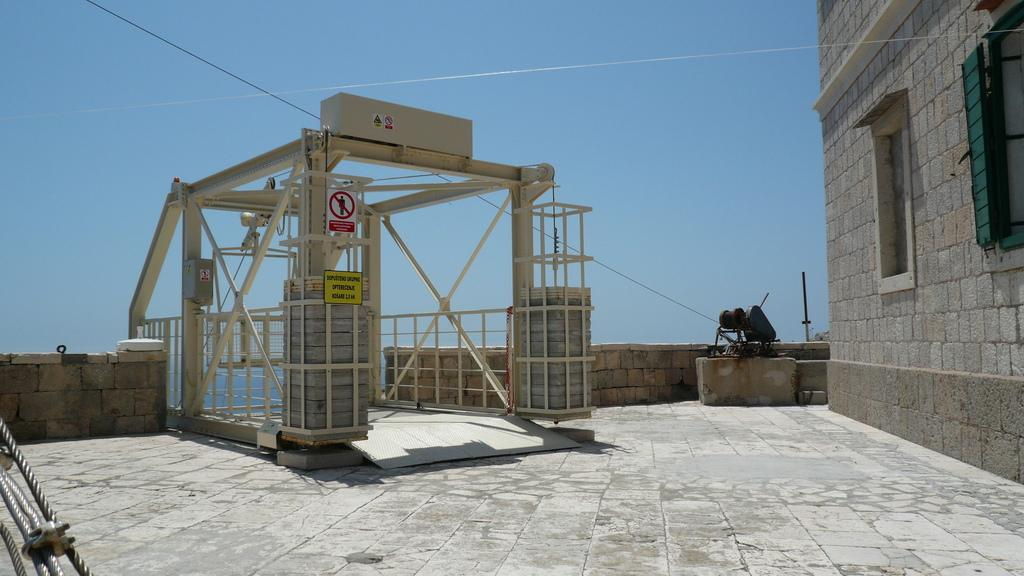What is the main structure in the center of the image? There is a shed in the center of the image. Are there any additional signs or markers near the shed? Yes, there are sign boards placed near the shed. What can be seen on the right side of the image? There is a building on the right side of the image. What type of material is visible in the image? There is a stone visible in the image. What is visible at the bottom of the image? The ground is visible at the bottom of the image. How many buttons can be seen on the shed in the image? There are no buttons present on the shed in the image. What type of nail is used to hold the sign boards in place in the image? There is no information about the type of nail used to hold the sign boards in place in the image. 